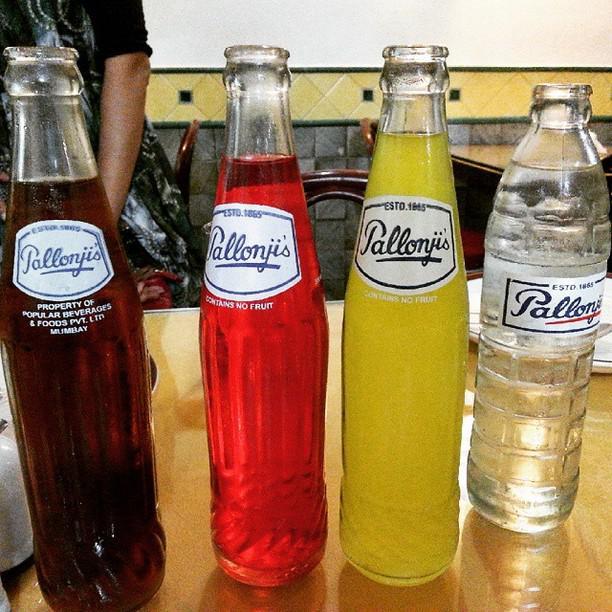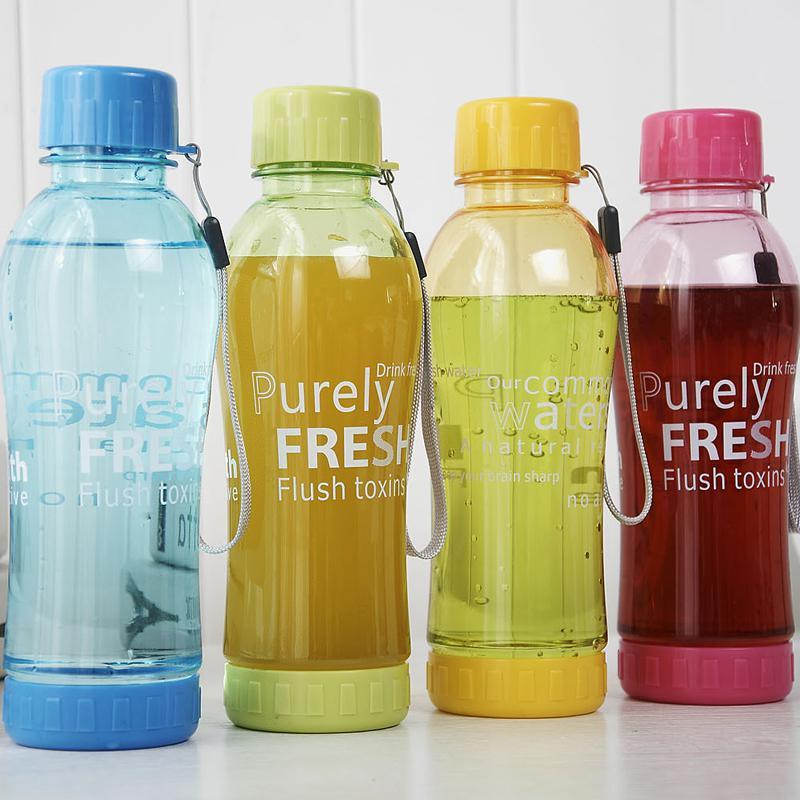The first image is the image on the left, the second image is the image on the right. Given the left and right images, does the statement "There are four uncapped bottles in the left image." hold true? Answer yes or no. Yes. The first image is the image on the left, the second image is the image on the right. Examine the images to the left and right. Is the description "There are nine drink bottles in total." accurate? Answer yes or no. No. 